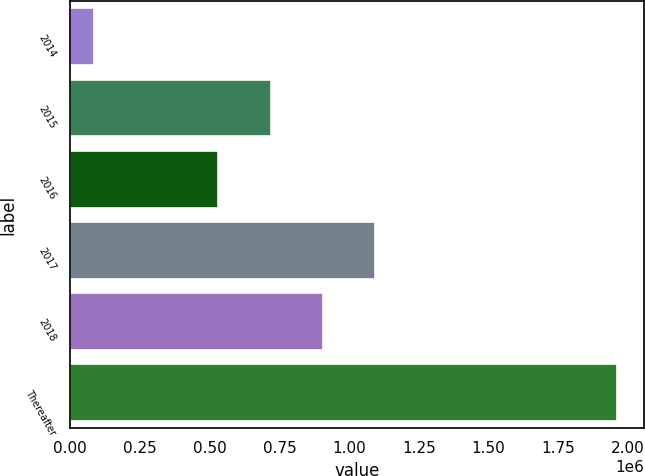Convert chart. <chart><loc_0><loc_0><loc_500><loc_500><bar_chart><fcel>2014<fcel>2015<fcel>2016<fcel>2017<fcel>2018<fcel>Thereafter<nl><fcel>84060<fcel>718134<fcel>530439<fcel>1.09352e+06<fcel>905828<fcel>1.96101e+06<nl></chart> 